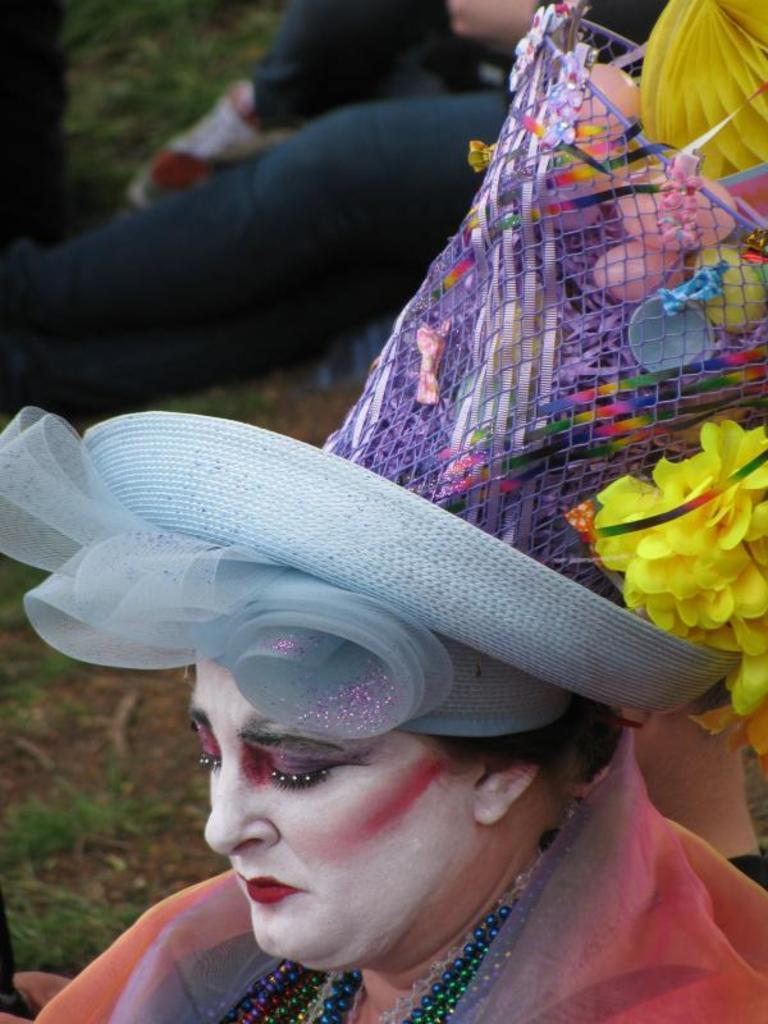Who is the main subject in the image? There is a lady in the image. What is the lady wearing on her head? The lady is wearing a hat. Are there any decorations on the hat? Yes, there are flowers on the hat. Can you describe the background of the image? The background of the image is blurry. What is the current hour according to the lady's watch in the image? There is no watch visible in the image, so it is not possible to determine the current hour. 